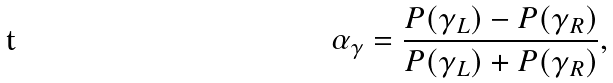<formula> <loc_0><loc_0><loc_500><loc_500>\alpha _ { \gamma } = \frac { P ( \gamma _ { L } ) - P ( \gamma _ { R } ) } { P ( \gamma _ { L } ) + P ( \gamma _ { R } ) } ,</formula> 